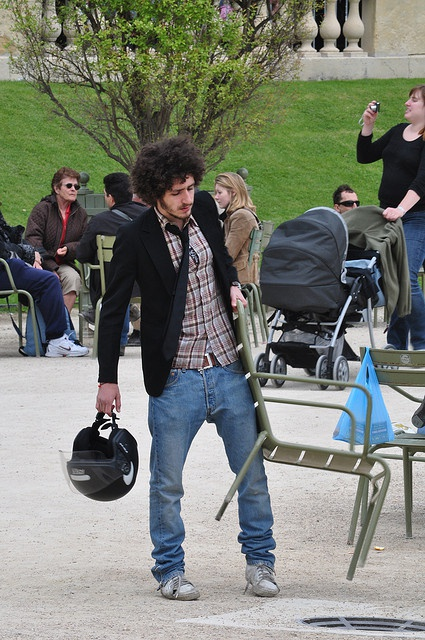Describe the objects in this image and their specific colors. I can see people in darkgray, black, and gray tones, chair in darkgray, lightgray, gray, and black tones, people in darkgray, black, darkblue, gray, and navy tones, chair in darkgray, black, and gray tones, and people in darkgray, black, navy, and gray tones in this image. 